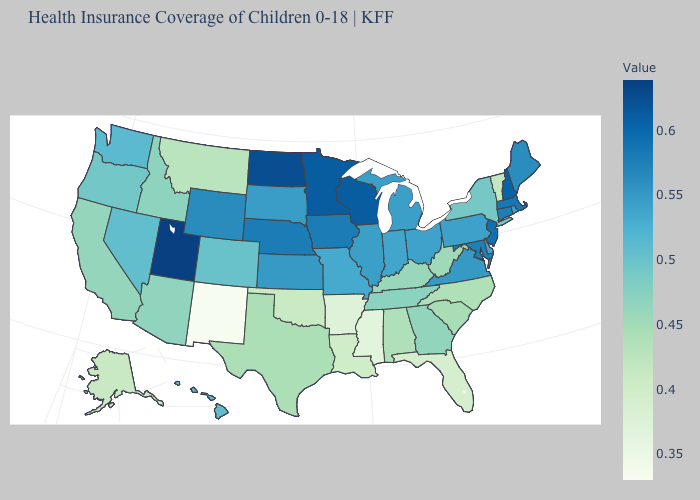Which states hav the highest value in the West?
Write a very short answer. Utah. Among the states that border Rhode Island , which have the highest value?
Answer briefly. Massachusetts. Among the states that border California , which have the lowest value?
Give a very brief answer. Arizona. Does Arkansas have a lower value than New Mexico?
Write a very short answer. No. 